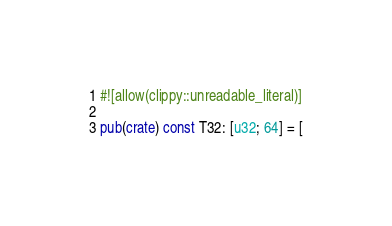<code> <loc_0><loc_0><loc_500><loc_500><_Rust_>#![allow(clippy::unreadable_literal)]

pub(crate) const T32: [u32; 64] = [</code> 